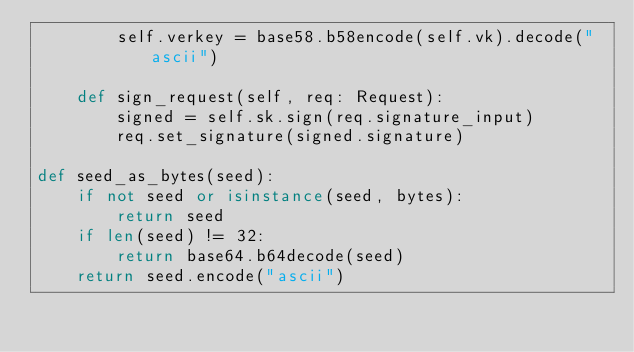<code> <loc_0><loc_0><loc_500><loc_500><_Python_>        self.verkey = base58.b58encode(self.vk).decode("ascii")

    def sign_request(self, req: Request):
        signed = self.sk.sign(req.signature_input)
        req.set_signature(signed.signature)

def seed_as_bytes(seed):
    if not seed or isinstance(seed, bytes):
        return seed
    if len(seed) != 32:
        return base64.b64decode(seed)
    return seed.encode("ascii")</code> 